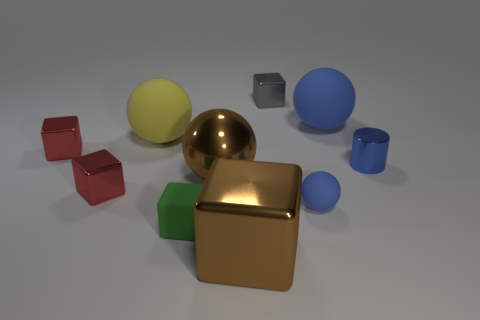Subtract all gray cubes. How many cubes are left? 4 Subtract all green cubes. How many cubes are left? 4 Subtract all red balls. Subtract all green blocks. How many balls are left? 4 Subtract all spheres. How many objects are left? 6 Add 9 brown balls. How many brown balls are left? 10 Add 3 cyan cubes. How many cyan cubes exist? 3 Subtract 0 gray balls. How many objects are left? 10 Subtract all big brown metal things. Subtract all blue things. How many objects are left? 5 